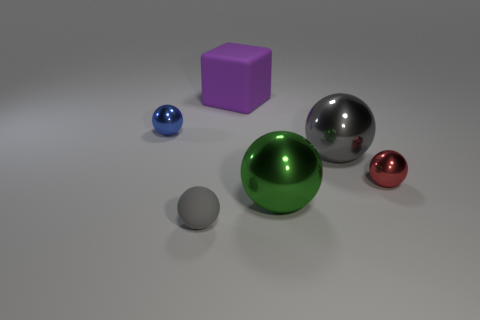There is another big object that is the same shape as the big green object; what material is it?
Provide a succinct answer. Metal. There is a thing that is behind the tiny object that is left of the small gray thing; how big is it?
Your answer should be compact. Large. There is a gray thing that is behind the red shiny sphere; what is it made of?
Your response must be concise. Metal. What size is the blue sphere that is the same material as the red thing?
Your response must be concise. Small. How many green objects are the same shape as the small blue thing?
Provide a succinct answer. 1. Do the big purple rubber thing and the rubber object in front of the red metallic sphere have the same shape?
Give a very brief answer. No. There is a shiny thing that is the same color as the small rubber object; what is its shape?
Provide a succinct answer. Sphere. Are there any large brown balls that have the same material as the small red ball?
Offer a very short reply. No. What material is the thing that is on the left side of the matte object that is to the left of the large purple rubber object made of?
Your response must be concise. Metal. How big is the metal ball in front of the tiny shiny thing that is right of the rubber object that is on the left side of the purple cube?
Ensure brevity in your answer.  Large. 